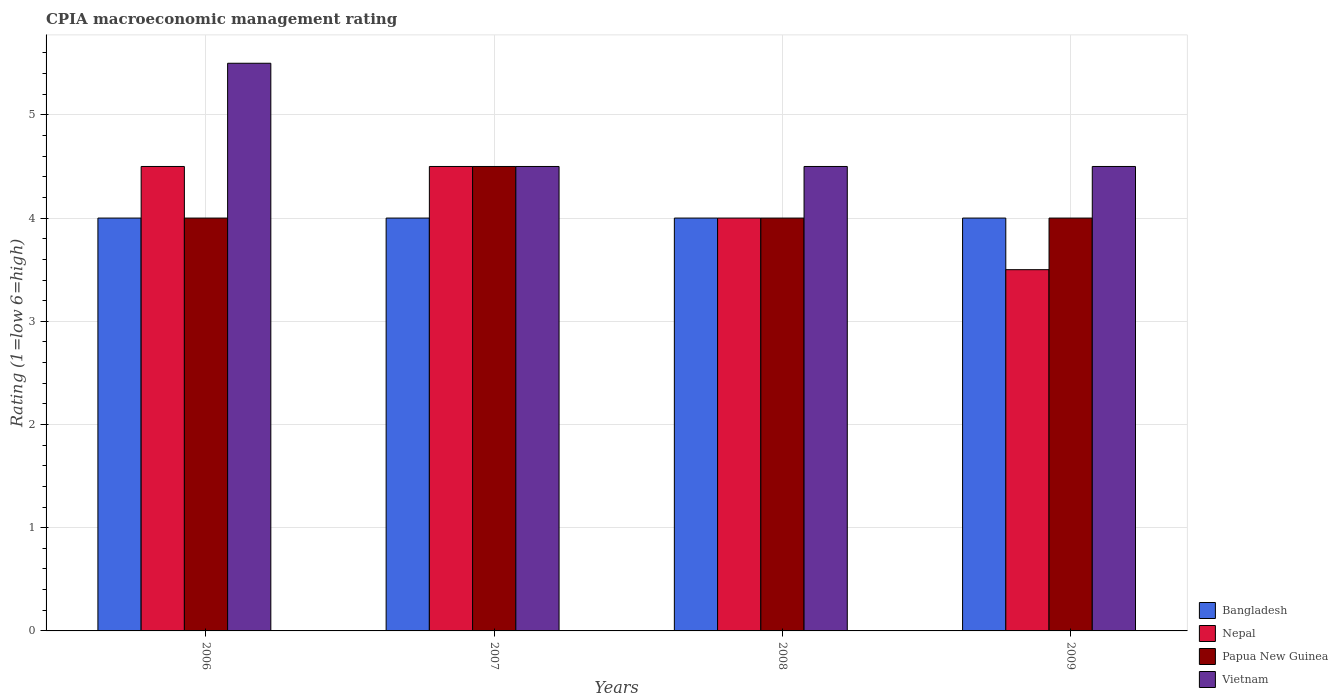Are the number of bars per tick equal to the number of legend labels?
Offer a very short reply. Yes. Are the number of bars on each tick of the X-axis equal?
Give a very brief answer. Yes. What is the label of the 4th group of bars from the left?
Offer a terse response. 2009. In how many cases, is the number of bars for a given year not equal to the number of legend labels?
Give a very brief answer. 0. What is the CPIA rating in Vietnam in 2009?
Your answer should be very brief. 4.5. What is the total CPIA rating in Bangladesh in the graph?
Your answer should be compact. 16. What is the difference between the CPIA rating in Vietnam in 2007 and that in 2009?
Ensure brevity in your answer.  0. What is the average CPIA rating in Papua New Guinea per year?
Offer a very short reply. 4.12. What is the ratio of the CPIA rating in Vietnam in 2006 to that in 2007?
Provide a succinct answer. 1.22. What is the difference between the highest and the second highest CPIA rating in Bangladesh?
Make the answer very short. 0. Is the sum of the CPIA rating in Papua New Guinea in 2006 and 2008 greater than the maximum CPIA rating in Vietnam across all years?
Give a very brief answer. Yes. Is it the case that in every year, the sum of the CPIA rating in Nepal and CPIA rating in Bangladesh is greater than the sum of CPIA rating in Vietnam and CPIA rating in Papua New Guinea?
Offer a terse response. No. What does the 4th bar from the left in 2006 represents?
Keep it short and to the point. Vietnam. What does the 4th bar from the right in 2009 represents?
Your response must be concise. Bangladesh. Is it the case that in every year, the sum of the CPIA rating in Bangladesh and CPIA rating in Papua New Guinea is greater than the CPIA rating in Nepal?
Keep it short and to the point. Yes. How many bars are there?
Your answer should be compact. 16. How many years are there in the graph?
Give a very brief answer. 4. What is the difference between two consecutive major ticks on the Y-axis?
Offer a very short reply. 1. Does the graph contain any zero values?
Make the answer very short. No. How are the legend labels stacked?
Keep it short and to the point. Vertical. What is the title of the graph?
Provide a succinct answer. CPIA macroeconomic management rating. Does "Low & middle income" appear as one of the legend labels in the graph?
Give a very brief answer. No. What is the Rating (1=low 6=high) in Bangladesh in 2006?
Your answer should be very brief. 4. What is the Rating (1=low 6=high) of Papua New Guinea in 2006?
Offer a terse response. 4. What is the Rating (1=low 6=high) in Vietnam in 2006?
Offer a very short reply. 5.5. What is the Rating (1=low 6=high) in Nepal in 2007?
Ensure brevity in your answer.  4.5. What is the Rating (1=low 6=high) of Papua New Guinea in 2007?
Keep it short and to the point. 4.5. What is the Rating (1=low 6=high) of Vietnam in 2007?
Ensure brevity in your answer.  4.5. What is the Rating (1=low 6=high) of Nepal in 2008?
Your answer should be compact. 4. What is the Rating (1=low 6=high) in Vietnam in 2008?
Your answer should be very brief. 4.5. Across all years, what is the maximum Rating (1=low 6=high) of Bangladesh?
Offer a terse response. 4. Across all years, what is the maximum Rating (1=low 6=high) in Papua New Guinea?
Give a very brief answer. 4.5. Across all years, what is the minimum Rating (1=low 6=high) in Papua New Guinea?
Make the answer very short. 4. Across all years, what is the minimum Rating (1=low 6=high) of Vietnam?
Give a very brief answer. 4.5. What is the total Rating (1=low 6=high) of Vietnam in the graph?
Offer a terse response. 19. What is the difference between the Rating (1=low 6=high) in Nepal in 2006 and that in 2007?
Your answer should be compact. 0. What is the difference between the Rating (1=low 6=high) of Vietnam in 2006 and that in 2007?
Keep it short and to the point. 1. What is the difference between the Rating (1=low 6=high) of Bangladesh in 2006 and that in 2008?
Offer a terse response. 0. What is the difference between the Rating (1=low 6=high) of Vietnam in 2006 and that in 2008?
Offer a terse response. 1. What is the difference between the Rating (1=low 6=high) of Bangladesh in 2006 and that in 2009?
Your answer should be very brief. 0. What is the difference between the Rating (1=low 6=high) of Nepal in 2006 and that in 2009?
Make the answer very short. 1. What is the difference between the Rating (1=low 6=high) of Papua New Guinea in 2006 and that in 2009?
Offer a terse response. 0. What is the difference between the Rating (1=low 6=high) of Vietnam in 2006 and that in 2009?
Keep it short and to the point. 1. What is the difference between the Rating (1=low 6=high) of Bangladesh in 2007 and that in 2008?
Offer a very short reply. 0. What is the difference between the Rating (1=low 6=high) in Vietnam in 2007 and that in 2008?
Your answer should be very brief. 0. What is the difference between the Rating (1=low 6=high) in Bangladesh in 2007 and that in 2009?
Give a very brief answer. 0. What is the difference between the Rating (1=low 6=high) of Nepal in 2008 and that in 2009?
Offer a terse response. 0.5. What is the difference between the Rating (1=low 6=high) of Vietnam in 2008 and that in 2009?
Give a very brief answer. 0. What is the difference between the Rating (1=low 6=high) of Bangladesh in 2006 and the Rating (1=low 6=high) of Nepal in 2007?
Ensure brevity in your answer.  -0.5. What is the difference between the Rating (1=low 6=high) in Bangladesh in 2006 and the Rating (1=low 6=high) in Papua New Guinea in 2007?
Offer a terse response. -0.5. What is the difference between the Rating (1=low 6=high) of Papua New Guinea in 2006 and the Rating (1=low 6=high) of Vietnam in 2007?
Your response must be concise. -0.5. What is the difference between the Rating (1=low 6=high) in Bangladesh in 2006 and the Rating (1=low 6=high) in Nepal in 2008?
Offer a terse response. 0. What is the difference between the Rating (1=low 6=high) of Bangladesh in 2006 and the Rating (1=low 6=high) of Papua New Guinea in 2008?
Provide a short and direct response. 0. What is the difference between the Rating (1=low 6=high) of Bangladesh in 2006 and the Rating (1=low 6=high) of Vietnam in 2008?
Your response must be concise. -0.5. What is the difference between the Rating (1=low 6=high) of Nepal in 2006 and the Rating (1=low 6=high) of Vietnam in 2008?
Offer a very short reply. 0. What is the difference between the Rating (1=low 6=high) of Bangladesh in 2006 and the Rating (1=low 6=high) of Nepal in 2009?
Offer a very short reply. 0.5. What is the difference between the Rating (1=low 6=high) of Bangladesh in 2006 and the Rating (1=low 6=high) of Papua New Guinea in 2009?
Make the answer very short. 0. What is the difference between the Rating (1=low 6=high) of Nepal in 2006 and the Rating (1=low 6=high) of Papua New Guinea in 2009?
Your response must be concise. 0.5. What is the difference between the Rating (1=low 6=high) in Papua New Guinea in 2006 and the Rating (1=low 6=high) in Vietnam in 2009?
Offer a terse response. -0.5. What is the difference between the Rating (1=low 6=high) in Bangladesh in 2007 and the Rating (1=low 6=high) in Nepal in 2008?
Your response must be concise. 0. What is the difference between the Rating (1=low 6=high) of Bangladesh in 2007 and the Rating (1=low 6=high) of Papua New Guinea in 2008?
Your answer should be compact. 0. What is the difference between the Rating (1=low 6=high) of Bangladesh in 2007 and the Rating (1=low 6=high) of Vietnam in 2008?
Make the answer very short. -0.5. What is the difference between the Rating (1=low 6=high) of Bangladesh in 2007 and the Rating (1=low 6=high) of Papua New Guinea in 2009?
Provide a short and direct response. 0. What is the difference between the Rating (1=low 6=high) of Nepal in 2007 and the Rating (1=low 6=high) of Papua New Guinea in 2009?
Provide a short and direct response. 0.5. What is the difference between the Rating (1=low 6=high) in Bangladesh in 2008 and the Rating (1=low 6=high) in Papua New Guinea in 2009?
Provide a succinct answer. 0. What is the difference between the Rating (1=low 6=high) in Bangladesh in 2008 and the Rating (1=low 6=high) in Vietnam in 2009?
Give a very brief answer. -0.5. What is the difference between the Rating (1=low 6=high) in Nepal in 2008 and the Rating (1=low 6=high) in Papua New Guinea in 2009?
Provide a succinct answer. 0. What is the difference between the Rating (1=low 6=high) of Nepal in 2008 and the Rating (1=low 6=high) of Vietnam in 2009?
Make the answer very short. -0.5. What is the difference between the Rating (1=low 6=high) in Papua New Guinea in 2008 and the Rating (1=low 6=high) in Vietnam in 2009?
Provide a short and direct response. -0.5. What is the average Rating (1=low 6=high) of Bangladesh per year?
Keep it short and to the point. 4. What is the average Rating (1=low 6=high) in Nepal per year?
Offer a terse response. 4.12. What is the average Rating (1=low 6=high) in Papua New Guinea per year?
Make the answer very short. 4.12. What is the average Rating (1=low 6=high) in Vietnam per year?
Offer a very short reply. 4.75. In the year 2006, what is the difference between the Rating (1=low 6=high) of Bangladesh and Rating (1=low 6=high) of Papua New Guinea?
Your response must be concise. 0. In the year 2006, what is the difference between the Rating (1=low 6=high) in Bangladesh and Rating (1=low 6=high) in Vietnam?
Provide a succinct answer. -1.5. In the year 2006, what is the difference between the Rating (1=low 6=high) of Nepal and Rating (1=low 6=high) of Papua New Guinea?
Give a very brief answer. 0.5. In the year 2006, what is the difference between the Rating (1=low 6=high) of Papua New Guinea and Rating (1=low 6=high) of Vietnam?
Offer a terse response. -1.5. In the year 2007, what is the difference between the Rating (1=low 6=high) in Bangladesh and Rating (1=low 6=high) in Nepal?
Provide a short and direct response. -0.5. In the year 2007, what is the difference between the Rating (1=low 6=high) in Bangladesh and Rating (1=low 6=high) in Vietnam?
Provide a succinct answer. -0.5. In the year 2007, what is the difference between the Rating (1=low 6=high) in Nepal and Rating (1=low 6=high) in Papua New Guinea?
Provide a short and direct response. 0. In the year 2007, what is the difference between the Rating (1=low 6=high) in Nepal and Rating (1=low 6=high) in Vietnam?
Ensure brevity in your answer.  0. In the year 2008, what is the difference between the Rating (1=low 6=high) of Nepal and Rating (1=low 6=high) of Papua New Guinea?
Make the answer very short. 0. In the year 2008, what is the difference between the Rating (1=low 6=high) in Nepal and Rating (1=low 6=high) in Vietnam?
Offer a very short reply. -0.5. In the year 2009, what is the difference between the Rating (1=low 6=high) in Bangladesh and Rating (1=low 6=high) in Vietnam?
Your response must be concise. -0.5. In the year 2009, what is the difference between the Rating (1=low 6=high) in Nepal and Rating (1=low 6=high) in Vietnam?
Your answer should be very brief. -1. What is the ratio of the Rating (1=low 6=high) in Papua New Guinea in 2006 to that in 2007?
Provide a short and direct response. 0.89. What is the ratio of the Rating (1=low 6=high) in Vietnam in 2006 to that in 2007?
Offer a very short reply. 1.22. What is the ratio of the Rating (1=low 6=high) in Bangladesh in 2006 to that in 2008?
Ensure brevity in your answer.  1. What is the ratio of the Rating (1=low 6=high) in Nepal in 2006 to that in 2008?
Provide a short and direct response. 1.12. What is the ratio of the Rating (1=low 6=high) in Papua New Guinea in 2006 to that in 2008?
Your answer should be very brief. 1. What is the ratio of the Rating (1=low 6=high) in Vietnam in 2006 to that in 2008?
Keep it short and to the point. 1.22. What is the ratio of the Rating (1=low 6=high) in Bangladesh in 2006 to that in 2009?
Ensure brevity in your answer.  1. What is the ratio of the Rating (1=low 6=high) in Nepal in 2006 to that in 2009?
Offer a very short reply. 1.29. What is the ratio of the Rating (1=low 6=high) in Papua New Guinea in 2006 to that in 2009?
Offer a terse response. 1. What is the ratio of the Rating (1=low 6=high) in Vietnam in 2006 to that in 2009?
Offer a very short reply. 1.22. What is the ratio of the Rating (1=low 6=high) of Nepal in 2007 to that in 2008?
Your answer should be very brief. 1.12. What is the ratio of the Rating (1=low 6=high) of Nepal in 2007 to that in 2009?
Give a very brief answer. 1.29. What is the ratio of the Rating (1=low 6=high) of Vietnam in 2007 to that in 2009?
Provide a succinct answer. 1. What is the ratio of the Rating (1=low 6=high) of Bangladesh in 2008 to that in 2009?
Give a very brief answer. 1. What is the ratio of the Rating (1=low 6=high) in Papua New Guinea in 2008 to that in 2009?
Keep it short and to the point. 1. What is the ratio of the Rating (1=low 6=high) of Vietnam in 2008 to that in 2009?
Provide a succinct answer. 1. What is the difference between the highest and the second highest Rating (1=low 6=high) of Bangladesh?
Your answer should be compact. 0. What is the difference between the highest and the lowest Rating (1=low 6=high) in Bangladesh?
Your answer should be compact. 0. What is the difference between the highest and the lowest Rating (1=low 6=high) in Nepal?
Your answer should be compact. 1. 